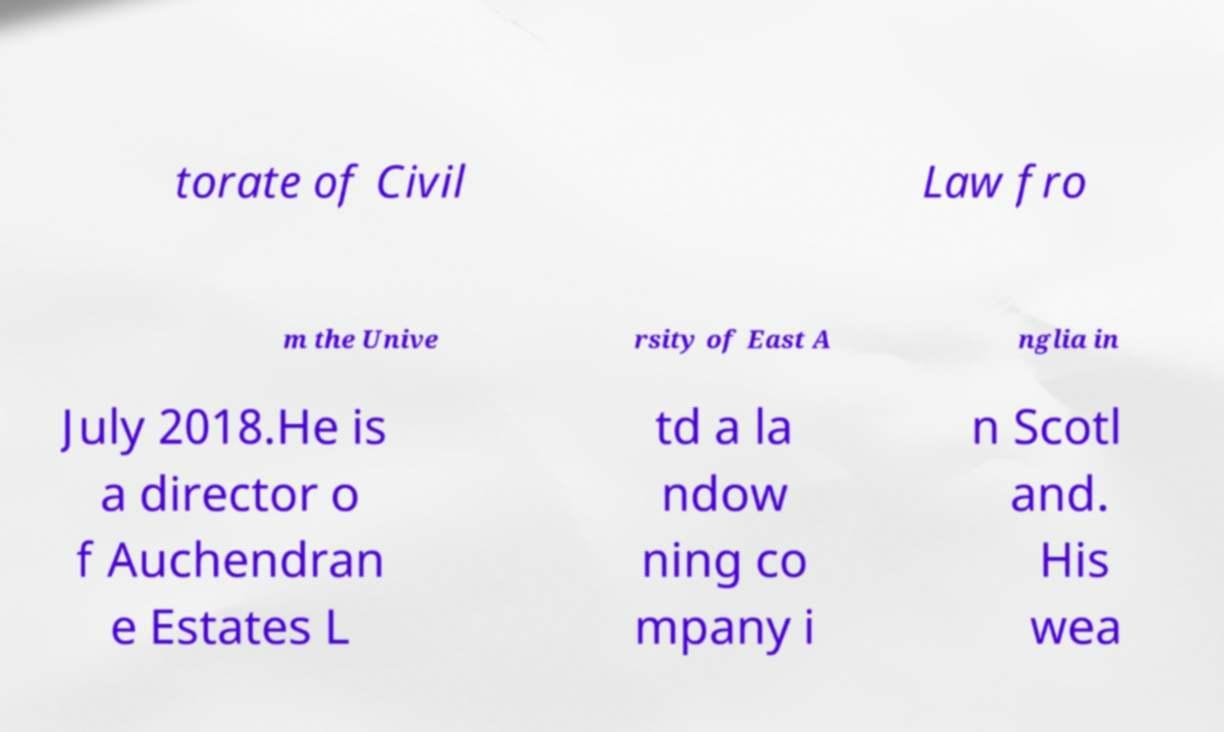Please read and relay the text visible in this image. What does it say? torate of Civil Law fro m the Unive rsity of East A nglia in July 2018.He is a director o f Auchendran e Estates L td a la ndow ning co mpany i n Scotl and. His wea 